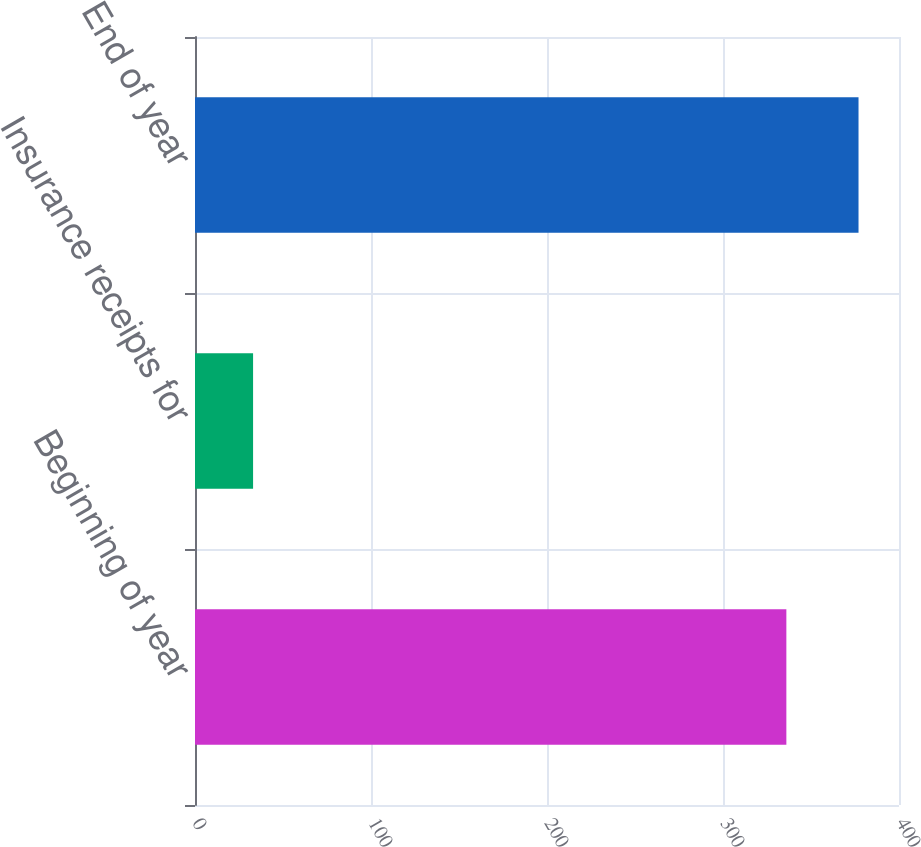<chart> <loc_0><loc_0><loc_500><loc_500><bar_chart><fcel>Beginning of year<fcel>Insurance receipts for<fcel>End of year<nl><fcel>336<fcel>33<fcel>377<nl></chart> 